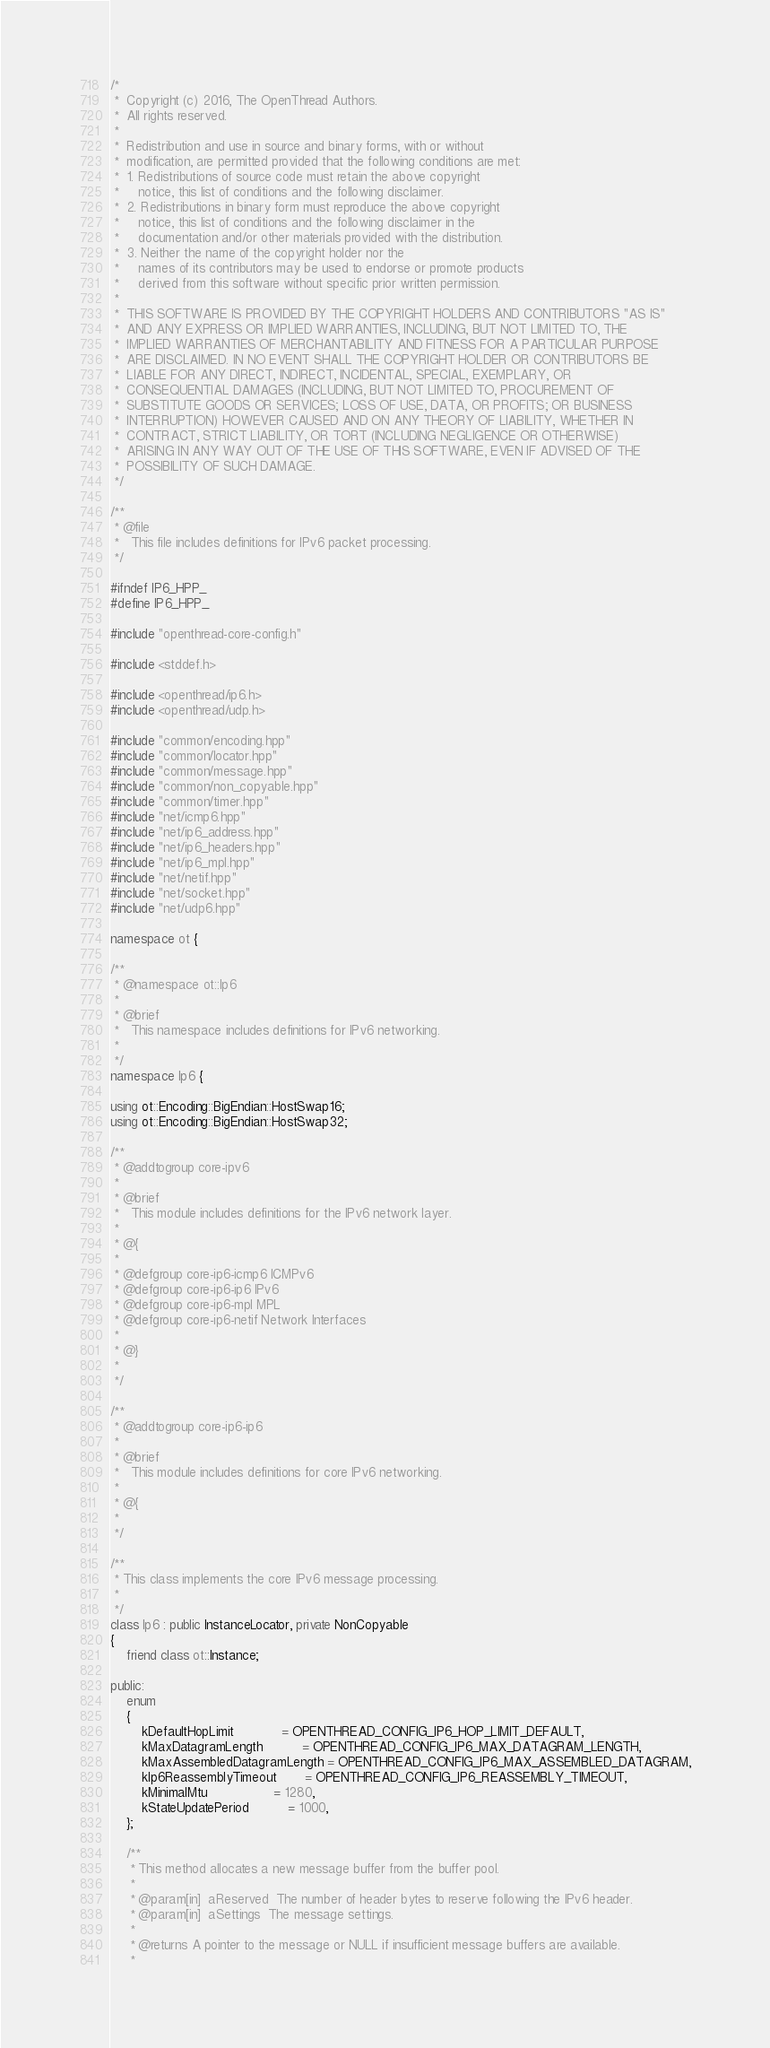<code> <loc_0><loc_0><loc_500><loc_500><_C++_>/*
 *  Copyright (c) 2016, The OpenThread Authors.
 *  All rights reserved.
 *
 *  Redistribution and use in source and binary forms, with or without
 *  modification, are permitted provided that the following conditions are met:
 *  1. Redistributions of source code must retain the above copyright
 *     notice, this list of conditions and the following disclaimer.
 *  2. Redistributions in binary form must reproduce the above copyright
 *     notice, this list of conditions and the following disclaimer in the
 *     documentation and/or other materials provided with the distribution.
 *  3. Neither the name of the copyright holder nor the
 *     names of its contributors may be used to endorse or promote products
 *     derived from this software without specific prior written permission.
 *
 *  THIS SOFTWARE IS PROVIDED BY THE COPYRIGHT HOLDERS AND CONTRIBUTORS "AS IS"
 *  AND ANY EXPRESS OR IMPLIED WARRANTIES, INCLUDING, BUT NOT LIMITED TO, THE
 *  IMPLIED WARRANTIES OF MERCHANTABILITY AND FITNESS FOR A PARTICULAR PURPOSE
 *  ARE DISCLAIMED. IN NO EVENT SHALL THE COPYRIGHT HOLDER OR CONTRIBUTORS BE
 *  LIABLE FOR ANY DIRECT, INDIRECT, INCIDENTAL, SPECIAL, EXEMPLARY, OR
 *  CONSEQUENTIAL DAMAGES (INCLUDING, BUT NOT LIMITED TO, PROCUREMENT OF
 *  SUBSTITUTE GOODS OR SERVICES; LOSS OF USE, DATA, OR PROFITS; OR BUSINESS
 *  INTERRUPTION) HOWEVER CAUSED AND ON ANY THEORY OF LIABILITY, WHETHER IN
 *  CONTRACT, STRICT LIABILITY, OR TORT (INCLUDING NEGLIGENCE OR OTHERWISE)
 *  ARISING IN ANY WAY OUT OF THE USE OF THIS SOFTWARE, EVEN IF ADVISED OF THE
 *  POSSIBILITY OF SUCH DAMAGE.
 */

/**
 * @file
 *   This file includes definitions for IPv6 packet processing.
 */

#ifndef IP6_HPP_
#define IP6_HPP_

#include "openthread-core-config.h"

#include <stddef.h>

#include <openthread/ip6.h>
#include <openthread/udp.h>

#include "common/encoding.hpp"
#include "common/locator.hpp"
#include "common/message.hpp"
#include "common/non_copyable.hpp"
#include "common/timer.hpp"
#include "net/icmp6.hpp"
#include "net/ip6_address.hpp"
#include "net/ip6_headers.hpp"
#include "net/ip6_mpl.hpp"
#include "net/netif.hpp"
#include "net/socket.hpp"
#include "net/udp6.hpp"

namespace ot {

/**
 * @namespace ot::Ip6
 *
 * @brief
 *   This namespace includes definitions for IPv6 networking.
 *
 */
namespace Ip6 {

using ot::Encoding::BigEndian::HostSwap16;
using ot::Encoding::BigEndian::HostSwap32;

/**
 * @addtogroup core-ipv6
 *
 * @brief
 *   This module includes definitions for the IPv6 network layer.
 *
 * @{
 *
 * @defgroup core-ip6-icmp6 ICMPv6
 * @defgroup core-ip6-ip6 IPv6
 * @defgroup core-ip6-mpl MPL
 * @defgroup core-ip6-netif Network Interfaces
 *
 * @}
 *
 */

/**
 * @addtogroup core-ip6-ip6
 *
 * @brief
 *   This module includes definitions for core IPv6 networking.
 *
 * @{
 *
 */

/**
 * This class implements the core IPv6 message processing.
 *
 */
class Ip6 : public InstanceLocator, private NonCopyable
{
    friend class ot::Instance;

public:
    enum
    {
        kDefaultHopLimit            = OPENTHREAD_CONFIG_IP6_HOP_LIMIT_DEFAULT,
        kMaxDatagramLength          = OPENTHREAD_CONFIG_IP6_MAX_DATAGRAM_LENGTH,
        kMaxAssembledDatagramLength = OPENTHREAD_CONFIG_IP6_MAX_ASSEMBLED_DATAGRAM,
        kIp6ReassemblyTimeout       = OPENTHREAD_CONFIG_IP6_REASSEMBLY_TIMEOUT,
        kMinimalMtu                 = 1280,
        kStateUpdatePeriod          = 1000,
    };

    /**
     * This method allocates a new message buffer from the buffer pool.
     *
     * @param[in]  aReserved  The number of header bytes to reserve following the IPv6 header.
     * @param[in]  aSettings  The message settings.
     *
     * @returns A pointer to the message or NULL if insufficient message buffers are available.
     *</code> 